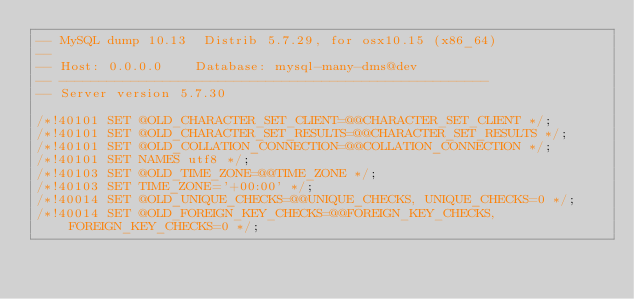<code> <loc_0><loc_0><loc_500><loc_500><_SQL_>-- MySQL dump 10.13  Distrib 5.7.29, for osx10.15 (x86_64)
--
-- Host: 0.0.0.0    Database: mysql-many-dms@dev
-- ------------------------------------------------------
-- Server version	5.7.30

/*!40101 SET @OLD_CHARACTER_SET_CLIENT=@@CHARACTER_SET_CLIENT */;
/*!40101 SET @OLD_CHARACTER_SET_RESULTS=@@CHARACTER_SET_RESULTS */;
/*!40101 SET @OLD_COLLATION_CONNECTION=@@COLLATION_CONNECTION */;
/*!40101 SET NAMES utf8 */;
/*!40103 SET @OLD_TIME_ZONE=@@TIME_ZONE */;
/*!40103 SET TIME_ZONE='+00:00' */;
/*!40014 SET @OLD_UNIQUE_CHECKS=@@UNIQUE_CHECKS, UNIQUE_CHECKS=0 */;
/*!40014 SET @OLD_FOREIGN_KEY_CHECKS=@@FOREIGN_KEY_CHECKS, FOREIGN_KEY_CHECKS=0 */;</code> 